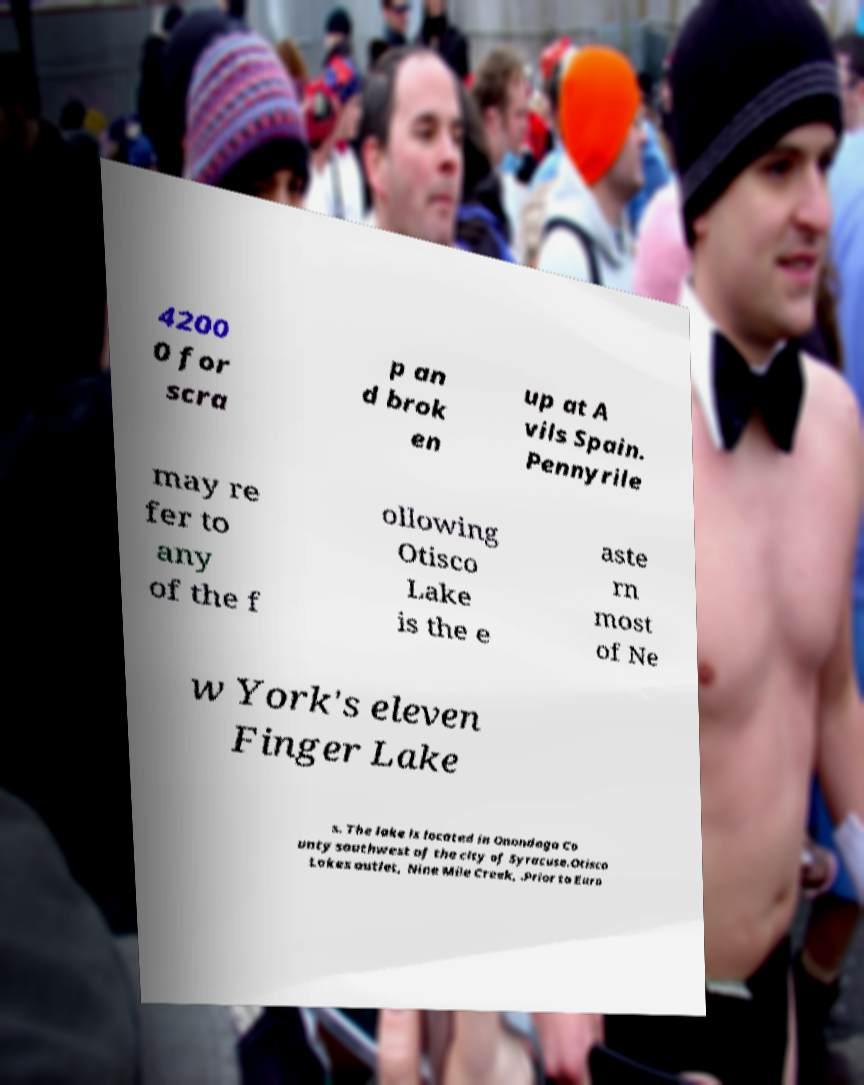I need the written content from this picture converted into text. Can you do that? 4200 0 for scra p an d brok en up at A vils Spain. Pennyrile may re fer to any of the f ollowing Otisco Lake is the e aste rn most of Ne w York's eleven Finger Lake s. The lake is located in Onondaga Co unty southwest of the city of Syracuse.Otisco Lakes outlet, Nine Mile Creek, .Prior to Euro 